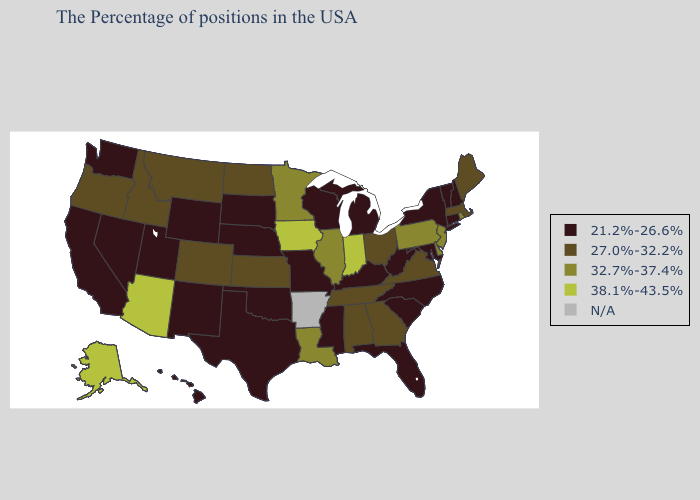Among the states that border New Mexico , which have the highest value?
Quick response, please. Arizona. What is the lowest value in the USA?
Concise answer only. 21.2%-26.6%. Name the states that have a value in the range 21.2%-26.6%?
Concise answer only. New Hampshire, Vermont, Connecticut, New York, Maryland, North Carolina, South Carolina, West Virginia, Florida, Michigan, Kentucky, Wisconsin, Mississippi, Missouri, Nebraska, Oklahoma, Texas, South Dakota, Wyoming, New Mexico, Utah, Nevada, California, Washington, Hawaii. Among the states that border Pennsylvania , does New Jersey have the lowest value?
Short answer required. No. Name the states that have a value in the range 38.1%-43.5%?
Short answer required. Indiana, Iowa, Arizona, Alaska. What is the value of Idaho?
Quick response, please. 27.0%-32.2%. What is the highest value in states that border Wyoming?
Answer briefly. 27.0%-32.2%. What is the value of West Virginia?
Answer briefly. 21.2%-26.6%. Among the states that border Maryland , does Delaware have the lowest value?
Quick response, please. No. Name the states that have a value in the range 32.7%-37.4%?
Short answer required. Rhode Island, New Jersey, Delaware, Pennsylvania, Illinois, Louisiana, Minnesota. What is the value of Nevada?
Be succinct. 21.2%-26.6%. Among the states that border Tennessee , which have the lowest value?
Write a very short answer. North Carolina, Kentucky, Mississippi, Missouri. Among the states that border Rhode Island , which have the lowest value?
Short answer required. Connecticut. Which states have the lowest value in the South?
Keep it brief. Maryland, North Carolina, South Carolina, West Virginia, Florida, Kentucky, Mississippi, Oklahoma, Texas. What is the value of Kansas?
Short answer required. 27.0%-32.2%. 